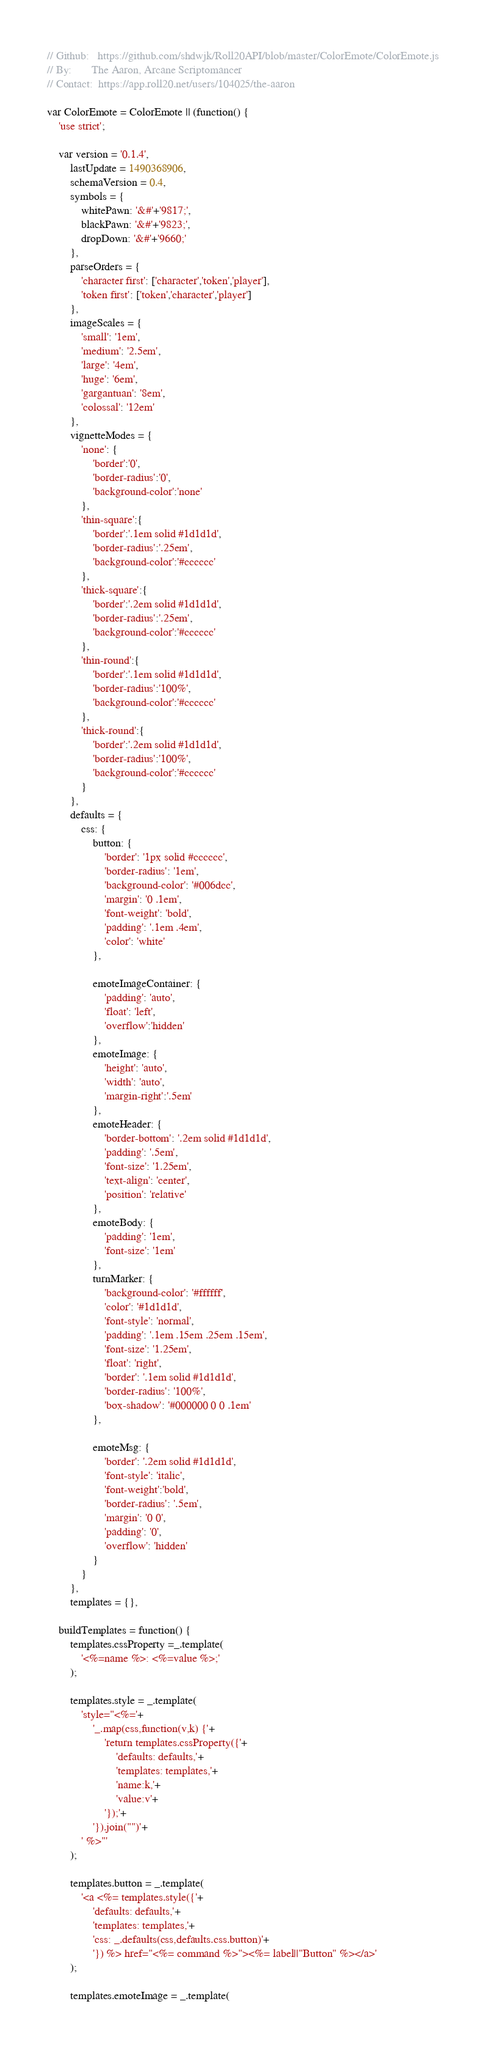Convert code to text. <code><loc_0><loc_0><loc_500><loc_500><_JavaScript_>// Github:   https://github.com/shdwjk/Roll20API/blob/master/ColorEmote/ColorEmote.js
// By:       The Aaron, Arcane Scriptomancer
// Contact:  https://app.roll20.net/users/104025/the-aaron

var ColorEmote = ColorEmote || (function() {
    'use strict';

    var version = '0.1.4',
        lastUpdate = 1490368906,
        schemaVersion = 0.4,
        symbols = {
            whitePawn: '&#'+'9817;',
            blackPawn: '&#'+'9823;',
            dropDown: '&#'+'9660;'
        },
        parseOrders = {
            'character first': ['character','token','player'],
            'token first': ['token','character','player']
        },
        imageScales = {
            'small': '1em',
            'medium': '2.5em',
            'large': '4em',
            'huge': '6em',
            'gargantuan': '8em',
            'colossal': '12em'
        },
        vignetteModes = {
            'none': {
                'border':'0',
                'border-radius':'0',
                'background-color':'none'
            },
            'thin-square':{
                'border':'.1em solid #1d1d1d',
                'border-radius':'.25em',
                'background-color':'#cccccc'
            },
            'thick-square':{
                'border':'.2em solid #1d1d1d',
                'border-radius':'.25em',
                'background-color':'#cccccc'
            },
            'thin-round':{
                'border':'.1em solid #1d1d1d',
                'border-radius':'100%',
                'background-color':'#cccccc'
            },
            'thick-round':{
                'border':'.2em solid #1d1d1d',
                'border-radius':'100%',
                'background-color':'#cccccc'
            }
        },
        defaults = {
            css: {
                button: {
                    'border': '1px solid #cccccc',
                    'border-radius': '1em',
                    'background-color': '#006dcc',
                    'margin': '0 .1em',
                    'font-weight': 'bold',
                    'padding': '.1em .4em',
                    'color': 'white'
                },

                emoteImageContainer: {
                    'padding': 'auto',
                    'float': 'left',
                    'overflow':'hidden'
                },
                emoteImage: {
                    'height': 'auto',
                    'width': 'auto',
                    'margin-right':'.5em'
                },
                emoteHeader: {
                    'border-bottom': '.2em solid #1d1d1d',
                    'padding': '.5em',
                    'font-size': '1.25em',
                    'text-align': 'center',
                    'position': 'relative'
                },
                emoteBody: {
                    'padding': '1em',
                    'font-size': '1em'
                },
                turnMarker: {
                    'background-color': '#ffffff',
                    'color': '#1d1d1d',
                    'font-style': 'normal',
                    'padding': '.1em .15em .25em .15em',
                    'font-size': '1.25em',
                    'float': 'right',
                    'border': '.1em solid #1d1d1d',
                    'border-radius': '100%',
                    'box-shadow': '#000000 0 0 .1em'
                },

                emoteMsg: {
                    'border': '.2em solid #1d1d1d',
                    'font-style': 'italic',
                    'font-weight':'bold',
                    'border-radius': '.5em',
                    'margin': '0 0',
                    'padding': '0',
                    'overflow': 'hidden'
                }
            }
        },
        templates = {},

    buildTemplates = function() {
        templates.cssProperty =_.template(
            '<%=name %>: <%=value %>;'
        );

        templates.style = _.template(
            'style="<%='+
                '_.map(css,function(v,k) {'+
                    'return templates.cssProperty({'+
                        'defaults: defaults,'+
                        'templates: templates,'+
                        'name:k,'+
                        'value:v'+
                    '});'+
                '}).join("")'+
            ' %>"'
        );

        templates.button = _.template(
            '<a <%= templates.style({'+
                'defaults: defaults,'+
                'templates: templates,'+
                'css: _.defaults(css,defaults.css.button)'+
                '}) %> href="<%= command %>"><%= label||"Button" %></a>'
        );

        templates.emoteImage = _.template(</code> 